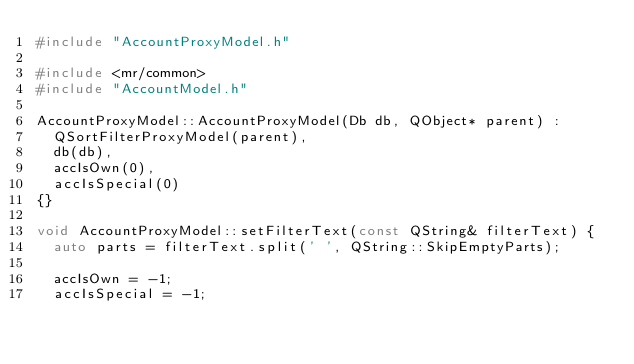Convert code to text. <code><loc_0><loc_0><loc_500><loc_500><_C++_>#include "AccountProxyModel.h"

#include <mr/common>
#include "AccountModel.h"

AccountProxyModel::AccountProxyModel(Db db, QObject* parent) :
	QSortFilterProxyModel(parent),
	db(db),
	accIsOwn(0),
	accIsSpecial(0)
{}

void AccountProxyModel::setFilterText(const QString& filterText) {
	auto parts = filterText.split(' ', QString::SkipEmptyParts);

	accIsOwn = -1;
	accIsSpecial = -1;</code> 